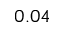Convert formula to latex. <formula><loc_0><loc_0><loc_500><loc_500>0 . 0 4</formula> 